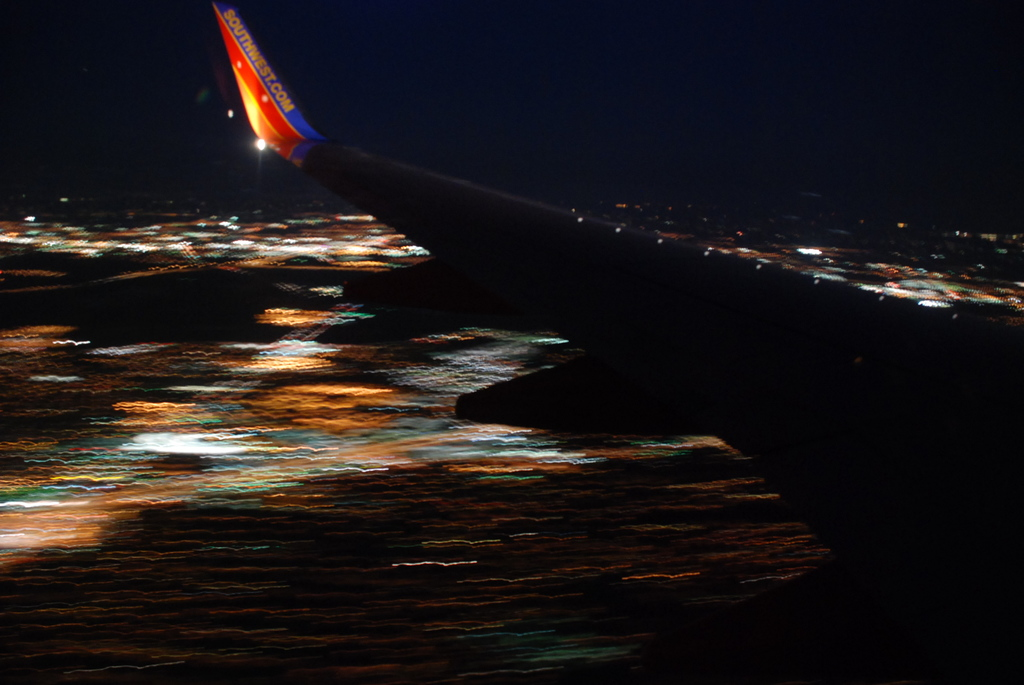Provide a one-sentence caption for the provided image. A nighttime view from the wing of a Southwest airplane, showcasing a twinkling tapestry of city lights below, blurred by the aircraft's motion. 